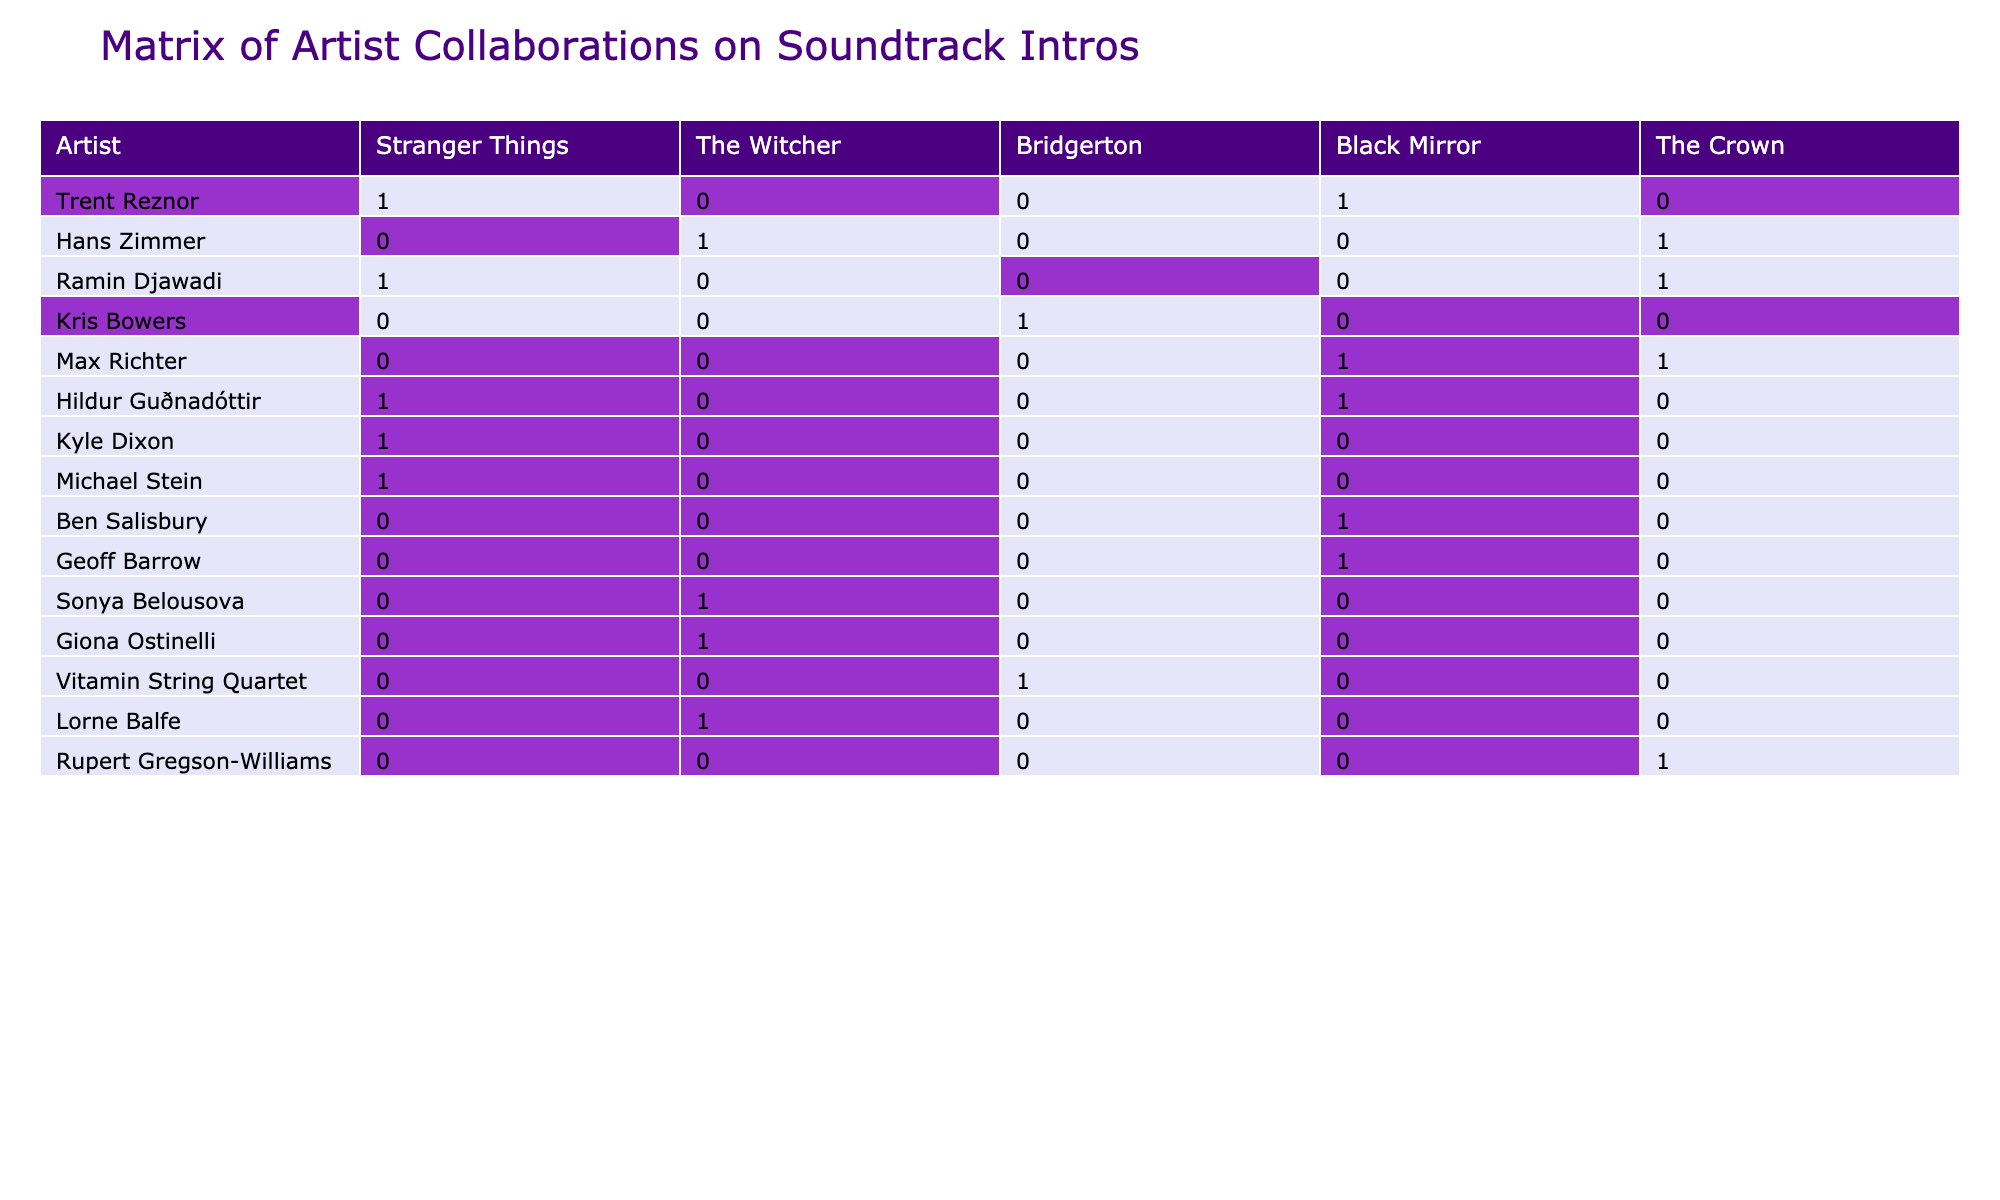What is the total number of artists that collaborated on the soundtrack intros for "Stranger Things"? By looking at the "Stranger Things" column, I can see which artists have a value of 1. Counting these entries gives us a total of 5 artists who contributed to the soundtrack intro for "Stranger Things".
Answer: 5 Which artist worked on both "The Witcher" and "The Crown"? I will scan the columns for both "The Witcher" and "The Crown". The artist "Hans Zimmer" appears with a value of 1 in both columns, so he is the one who collaborated on both soundtracks.
Answer: Hans Zimmer How many artists contributed to the "Black Mirror" soundtrack? I will check the "Black Mirror" column for entries that equal 1. Upon counting, there are 3 artists listed for "Black Mirror".
Answer: 3 Did Hildur Guðnadóttir work on the soundtrack for "Bridgerton"? Looking at the "Bridgerton" column, I can see the value under Hildur Guðnadóttir is 0, which means she did not contribute to that soundtrack.
Answer: No Which artist contributed the most across all soundtracks? To find this, I will count the number of times each artist has a value of 1 across all columns. By assessing the table, I see that "Ramin Djawadi" and "Max Richter" each contributed to 2 soundtracks, while others contributed to fewer, so there is no artist that solely stands out in maximum contributions.
Answer: Ramin Djawadi and Max Richter How many unique artists contributed to the soundtrack for "The Witcher" and "Bridgerton" combined? I first need to identify which artists contributed to each of these soundtracks. The total artists for "The Witcher" is 4, and for "Bridgerton" is also 3, but "Sonya Belousova" and "Giona Ostinelli" are overlaps, so total unique artists combined would be 5.
Answer: 5 Is there any artist who worked on both "Stranger Things" and "The Crown"? I will check the corresponding columns for shared artists. Only "Ramin Djawadi" appears in both "Stranger Things" and "The Crown" with a value of 1.
Answer: Yes What is the total number of collaborations by Kyle Dixon and Max Richter? I can see in Kyle Dixon's row, he has 4 for “Stranger Things” and 0 elsewhere, giving him a total of 1 collaboration. Max Richter shows 1 for "Black Mirror" and "The Crown", totaling 2 collaborations. The total combined thus becomes 1 (Kyle Dixon) + 2 (Max Richter) = 3.
Answer: 3 How many soundtracks feature a collaboration from "Vitamin String Quartet"? Checking the "Vitamin String Quartet" row reveals a value of 1 only for "Bridgerton", indicating they collaborated on only one soundtrack intro.
Answer: 1 What percentage of artists contributed to "Black Mirror" out of the total artists? There are 10 artists overall. Since 3 artists contributed to "Black Mirror", I calculate the percentage as (3/10) * 100 = 30%.
Answer: 30% 